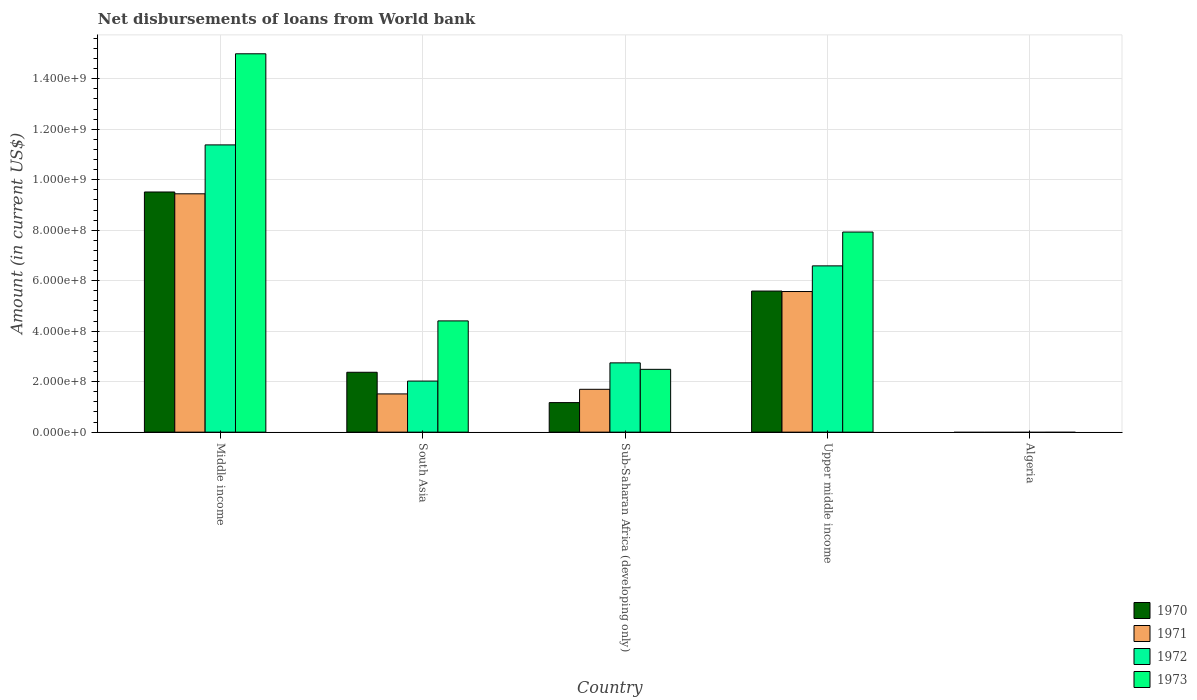How many different coloured bars are there?
Make the answer very short. 4. Are the number of bars on each tick of the X-axis equal?
Keep it short and to the point. No. How many bars are there on the 4th tick from the left?
Give a very brief answer. 4. How many bars are there on the 1st tick from the right?
Your response must be concise. 0. In how many cases, is the number of bars for a given country not equal to the number of legend labels?
Offer a terse response. 1. What is the amount of loan disbursed from World Bank in 1970 in Middle income?
Ensure brevity in your answer.  9.51e+08. Across all countries, what is the maximum amount of loan disbursed from World Bank in 1970?
Your answer should be very brief. 9.51e+08. In which country was the amount of loan disbursed from World Bank in 1973 maximum?
Give a very brief answer. Middle income. What is the total amount of loan disbursed from World Bank in 1973 in the graph?
Your response must be concise. 2.98e+09. What is the difference between the amount of loan disbursed from World Bank in 1971 in Sub-Saharan Africa (developing only) and that in Upper middle income?
Offer a terse response. -3.87e+08. What is the difference between the amount of loan disbursed from World Bank in 1972 in Upper middle income and the amount of loan disbursed from World Bank in 1971 in Middle income?
Provide a short and direct response. -2.85e+08. What is the average amount of loan disbursed from World Bank in 1973 per country?
Make the answer very short. 5.96e+08. What is the difference between the amount of loan disbursed from World Bank of/in 1973 and amount of loan disbursed from World Bank of/in 1971 in South Asia?
Ensure brevity in your answer.  2.89e+08. In how many countries, is the amount of loan disbursed from World Bank in 1970 greater than 40000000 US$?
Offer a very short reply. 4. What is the ratio of the amount of loan disbursed from World Bank in 1971 in Middle income to that in Upper middle income?
Offer a very short reply. 1.69. Is the difference between the amount of loan disbursed from World Bank in 1973 in Sub-Saharan Africa (developing only) and Upper middle income greater than the difference between the amount of loan disbursed from World Bank in 1971 in Sub-Saharan Africa (developing only) and Upper middle income?
Your answer should be very brief. No. What is the difference between the highest and the second highest amount of loan disbursed from World Bank in 1973?
Your answer should be very brief. 7.06e+08. What is the difference between the highest and the lowest amount of loan disbursed from World Bank in 1970?
Offer a very short reply. 9.51e+08. Is the sum of the amount of loan disbursed from World Bank in 1972 in South Asia and Upper middle income greater than the maximum amount of loan disbursed from World Bank in 1973 across all countries?
Give a very brief answer. No. Is it the case that in every country, the sum of the amount of loan disbursed from World Bank in 1970 and amount of loan disbursed from World Bank in 1973 is greater than the amount of loan disbursed from World Bank in 1972?
Provide a succinct answer. No. How many bars are there?
Offer a terse response. 16. How many countries are there in the graph?
Give a very brief answer. 5. What is the difference between two consecutive major ticks on the Y-axis?
Offer a very short reply. 2.00e+08. Are the values on the major ticks of Y-axis written in scientific E-notation?
Your answer should be compact. Yes. How many legend labels are there?
Give a very brief answer. 4. What is the title of the graph?
Your response must be concise. Net disbursements of loans from World bank. Does "2005" appear as one of the legend labels in the graph?
Ensure brevity in your answer.  No. What is the Amount (in current US$) in 1970 in Middle income?
Keep it short and to the point. 9.51e+08. What is the Amount (in current US$) of 1971 in Middle income?
Provide a succinct answer. 9.44e+08. What is the Amount (in current US$) of 1972 in Middle income?
Your response must be concise. 1.14e+09. What is the Amount (in current US$) in 1973 in Middle income?
Offer a very short reply. 1.50e+09. What is the Amount (in current US$) of 1970 in South Asia?
Make the answer very short. 2.37e+08. What is the Amount (in current US$) in 1971 in South Asia?
Provide a succinct answer. 1.51e+08. What is the Amount (in current US$) of 1972 in South Asia?
Make the answer very short. 2.02e+08. What is the Amount (in current US$) in 1973 in South Asia?
Your answer should be compact. 4.41e+08. What is the Amount (in current US$) in 1970 in Sub-Saharan Africa (developing only)?
Make the answer very short. 1.17e+08. What is the Amount (in current US$) of 1971 in Sub-Saharan Africa (developing only)?
Give a very brief answer. 1.70e+08. What is the Amount (in current US$) in 1972 in Sub-Saharan Africa (developing only)?
Provide a short and direct response. 2.74e+08. What is the Amount (in current US$) of 1973 in Sub-Saharan Africa (developing only)?
Keep it short and to the point. 2.49e+08. What is the Amount (in current US$) of 1970 in Upper middle income?
Provide a succinct answer. 5.59e+08. What is the Amount (in current US$) of 1971 in Upper middle income?
Provide a succinct answer. 5.57e+08. What is the Amount (in current US$) in 1972 in Upper middle income?
Offer a terse response. 6.59e+08. What is the Amount (in current US$) of 1973 in Upper middle income?
Offer a very short reply. 7.93e+08. What is the Amount (in current US$) in 1970 in Algeria?
Ensure brevity in your answer.  0. What is the Amount (in current US$) in 1972 in Algeria?
Provide a succinct answer. 0. What is the Amount (in current US$) of 1973 in Algeria?
Keep it short and to the point. 0. Across all countries, what is the maximum Amount (in current US$) of 1970?
Your response must be concise. 9.51e+08. Across all countries, what is the maximum Amount (in current US$) of 1971?
Offer a very short reply. 9.44e+08. Across all countries, what is the maximum Amount (in current US$) of 1972?
Keep it short and to the point. 1.14e+09. Across all countries, what is the maximum Amount (in current US$) of 1973?
Your response must be concise. 1.50e+09. Across all countries, what is the minimum Amount (in current US$) in 1970?
Ensure brevity in your answer.  0. Across all countries, what is the minimum Amount (in current US$) in 1971?
Offer a terse response. 0. Across all countries, what is the minimum Amount (in current US$) in 1972?
Offer a very short reply. 0. What is the total Amount (in current US$) of 1970 in the graph?
Your response must be concise. 1.86e+09. What is the total Amount (in current US$) in 1971 in the graph?
Provide a succinct answer. 1.82e+09. What is the total Amount (in current US$) in 1972 in the graph?
Ensure brevity in your answer.  2.27e+09. What is the total Amount (in current US$) in 1973 in the graph?
Ensure brevity in your answer.  2.98e+09. What is the difference between the Amount (in current US$) in 1970 in Middle income and that in South Asia?
Your response must be concise. 7.14e+08. What is the difference between the Amount (in current US$) in 1971 in Middle income and that in South Asia?
Ensure brevity in your answer.  7.93e+08. What is the difference between the Amount (in current US$) of 1972 in Middle income and that in South Asia?
Make the answer very short. 9.36e+08. What is the difference between the Amount (in current US$) in 1973 in Middle income and that in South Asia?
Your answer should be compact. 1.06e+09. What is the difference between the Amount (in current US$) of 1970 in Middle income and that in Sub-Saharan Africa (developing only)?
Ensure brevity in your answer.  8.34e+08. What is the difference between the Amount (in current US$) in 1971 in Middle income and that in Sub-Saharan Africa (developing only)?
Provide a short and direct response. 7.74e+08. What is the difference between the Amount (in current US$) in 1972 in Middle income and that in Sub-Saharan Africa (developing only)?
Ensure brevity in your answer.  8.63e+08. What is the difference between the Amount (in current US$) in 1973 in Middle income and that in Sub-Saharan Africa (developing only)?
Your response must be concise. 1.25e+09. What is the difference between the Amount (in current US$) in 1970 in Middle income and that in Upper middle income?
Provide a succinct answer. 3.92e+08. What is the difference between the Amount (in current US$) in 1971 in Middle income and that in Upper middle income?
Your answer should be very brief. 3.87e+08. What is the difference between the Amount (in current US$) in 1972 in Middle income and that in Upper middle income?
Your answer should be compact. 4.79e+08. What is the difference between the Amount (in current US$) of 1973 in Middle income and that in Upper middle income?
Provide a succinct answer. 7.06e+08. What is the difference between the Amount (in current US$) in 1970 in South Asia and that in Sub-Saharan Africa (developing only)?
Offer a terse response. 1.20e+08. What is the difference between the Amount (in current US$) of 1971 in South Asia and that in Sub-Saharan Africa (developing only)?
Ensure brevity in your answer.  -1.83e+07. What is the difference between the Amount (in current US$) of 1972 in South Asia and that in Sub-Saharan Africa (developing only)?
Keep it short and to the point. -7.21e+07. What is the difference between the Amount (in current US$) of 1973 in South Asia and that in Sub-Saharan Africa (developing only)?
Keep it short and to the point. 1.92e+08. What is the difference between the Amount (in current US$) of 1970 in South Asia and that in Upper middle income?
Your answer should be compact. -3.22e+08. What is the difference between the Amount (in current US$) of 1971 in South Asia and that in Upper middle income?
Offer a terse response. -4.06e+08. What is the difference between the Amount (in current US$) of 1972 in South Asia and that in Upper middle income?
Give a very brief answer. -4.56e+08. What is the difference between the Amount (in current US$) of 1973 in South Asia and that in Upper middle income?
Provide a short and direct response. -3.52e+08. What is the difference between the Amount (in current US$) of 1970 in Sub-Saharan Africa (developing only) and that in Upper middle income?
Provide a short and direct response. -4.42e+08. What is the difference between the Amount (in current US$) in 1971 in Sub-Saharan Africa (developing only) and that in Upper middle income?
Give a very brief answer. -3.87e+08. What is the difference between the Amount (in current US$) of 1972 in Sub-Saharan Africa (developing only) and that in Upper middle income?
Your response must be concise. -3.84e+08. What is the difference between the Amount (in current US$) in 1973 in Sub-Saharan Africa (developing only) and that in Upper middle income?
Your answer should be very brief. -5.44e+08. What is the difference between the Amount (in current US$) in 1970 in Middle income and the Amount (in current US$) in 1971 in South Asia?
Provide a succinct answer. 8.00e+08. What is the difference between the Amount (in current US$) in 1970 in Middle income and the Amount (in current US$) in 1972 in South Asia?
Make the answer very short. 7.49e+08. What is the difference between the Amount (in current US$) in 1970 in Middle income and the Amount (in current US$) in 1973 in South Asia?
Provide a succinct answer. 5.11e+08. What is the difference between the Amount (in current US$) of 1971 in Middle income and the Amount (in current US$) of 1972 in South Asia?
Make the answer very short. 7.42e+08. What is the difference between the Amount (in current US$) in 1971 in Middle income and the Amount (in current US$) in 1973 in South Asia?
Offer a very short reply. 5.03e+08. What is the difference between the Amount (in current US$) of 1972 in Middle income and the Amount (in current US$) of 1973 in South Asia?
Offer a very short reply. 6.97e+08. What is the difference between the Amount (in current US$) of 1970 in Middle income and the Amount (in current US$) of 1971 in Sub-Saharan Africa (developing only)?
Offer a very short reply. 7.82e+08. What is the difference between the Amount (in current US$) of 1970 in Middle income and the Amount (in current US$) of 1972 in Sub-Saharan Africa (developing only)?
Ensure brevity in your answer.  6.77e+08. What is the difference between the Amount (in current US$) in 1970 in Middle income and the Amount (in current US$) in 1973 in Sub-Saharan Africa (developing only)?
Provide a succinct answer. 7.03e+08. What is the difference between the Amount (in current US$) in 1971 in Middle income and the Amount (in current US$) in 1972 in Sub-Saharan Africa (developing only)?
Make the answer very short. 6.70e+08. What is the difference between the Amount (in current US$) of 1971 in Middle income and the Amount (in current US$) of 1973 in Sub-Saharan Africa (developing only)?
Make the answer very short. 6.95e+08. What is the difference between the Amount (in current US$) in 1972 in Middle income and the Amount (in current US$) in 1973 in Sub-Saharan Africa (developing only)?
Offer a terse response. 8.89e+08. What is the difference between the Amount (in current US$) of 1970 in Middle income and the Amount (in current US$) of 1971 in Upper middle income?
Keep it short and to the point. 3.94e+08. What is the difference between the Amount (in current US$) in 1970 in Middle income and the Amount (in current US$) in 1972 in Upper middle income?
Your answer should be compact. 2.93e+08. What is the difference between the Amount (in current US$) of 1970 in Middle income and the Amount (in current US$) of 1973 in Upper middle income?
Keep it short and to the point. 1.59e+08. What is the difference between the Amount (in current US$) of 1971 in Middle income and the Amount (in current US$) of 1972 in Upper middle income?
Give a very brief answer. 2.85e+08. What is the difference between the Amount (in current US$) in 1971 in Middle income and the Amount (in current US$) in 1973 in Upper middle income?
Provide a short and direct response. 1.51e+08. What is the difference between the Amount (in current US$) of 1972 in Middle income and the Amount (in current US$) of 1973 in Upper middle income?
Your response must be concise. 3.45e+08. What is the difference between the Amount (in current US$) of 1970 in South Asia and the Amount (in current US$) of 1971 in Sub-Saharan Africa (developing only)?
Offer a very short reply. 6.75e+07. What is the difference between the Amount (in current US$) of 1970 in South Asia and the Amount (in current US$) of 1972 in Sub-Saharan Africa (developing only)?
Offer a very short reply. -3.73e+07. What is the difference between the Amount (in current US$) in 1970 in South Asia and the Amount (in current US$) in 1973 in Sub-Saharan Africa (developing only)?
Make the answer very short. -1.16e+07. What is the difference between the Amount (in current US$) in 1971 in South Asia and the Amount (in current US$) in 1972 in Sub-Saharan Africa (developing only)?
Your response must be concise. -1.23e+08. What is the difference between the Amount (in current US$) in 1971 in South Asia and the Amount (in current US$) in 1973 in Sub-Saharan Africa (developing only)?
Your response must be concise. -9.74e+07. What is the difference between the Amount (in current US$) of 1972 in South Asia and the Amount (in current US$) of 1973 in Sub-Saharan Africa (developing only)?
Keep it short and to the point. -4.65e+07. What is the difference between the Amount (in current US$) in 1970 in South Asia and the Amount (in current US$) in 1971 in Upper middle income?
Offer a very short reply. -3.20e+08. What is the difference between the Amount (in current US$) in 1970 in South Asia and the Amount (in current US$) in 1972 in Upper middle income?
Offer a terse response. -4.22e+08. What is the difference between the Amount (in current US$) of 1970 in South Asia and the Amount (in current US$) of 1973 in Upper middle income?
Ensure brevity in your answer.  -5.56e+08. What is the difference between the Amount (in current US$) of 1971 in South Asia and the Amount (in current US$) of 1972 in Upper middle income?
Provide a succinct answer. -5.07e+08. What is the difference between the Amount (in current US$) of 1971 in South Asia and the Amount (in current US$) of 1973 in Upper middle income?
Your response must be concise. -6.41e+08. What is the difference between the Amount (in current US$) of 1972 in South Asia and the Amount (in current US$) of 1973 in Upper middle income?
Give a very brief answer. -5.90e+08. What is the difference between the Amount (in current US$) of 1970 in Sub-Saharan Africa (developing only) and the Amount (in current US$) of 1971 in Upper middle income?
Provide a short and direct response. -4.40e+08. What is the difference between the Amount (in current US$) in 1970 in Sub-Saharan Africa (developing only) and the Amount (in current US$) in 1972 in Upper middle income?
Provide a succinct answer. -5.42e+08. What is the difference between the Amount (in current US$) in 1970 in Sub-Saharan Africa (developing only) and the Amount (in current US$) in 1973 in Upper middle income?
Offer a terse response. -6.76e+08. What is the difference between the Amount (in current US$) in 1971 in Sub-Saharan Africa (developing only) and the Amount (in current US$) in 1972 in Upper middle income?
Make the answer very short. -4.89e+08. What is the difference between the Amount (in current US$) in 1971 in Sub-Saharan Africa (developing only) and the Amount (in current US$) in 1973 in Upper middle income?
Make the answer very short. -6.23e+08. What is the difference between the Amount (in current US$) of 1972 in Sub-Saharan Africa (developing only) and the Amount (in current US$) of 1973 in Upper middle income?
Offer a very short reply. -5.18e+08. What is the average Amount (in current US$) in 1970 per country?
Your answer should be compact. 3.73e+08. What is the average Amount (in current US$) of 1971 per country?
Offer a very short reply. 3.64e+08. What is the average Amount (in current US$) in 1972 per country?
Provide a short and direct response. 4.55e+08. What is the average Amount (in current US$) in 1973 per country?
Ensure brevity in your answer.  5.96e+08. What is the difference between the Amount (in current US$) of 1970 and Amount (in current US$) of 1971 in Middle income?
Offer a terse response. 7.21e+06. What is the difference between the Amount (in current US$) of 1970 and Amount (in current US$) of 1972 in Middle income?
Your answer should be compact. -1.87e+08. What is the difference between the Amount (in current US$) of 1970 and Amount (in current US$) of 1973 in Middle income?
Your answer should be very brief. -5.47e+08. What is the difference between the Amount (in current US$) in 1971 and Amount (in current US$) in 1972 in Middle income?
Your answer should be very brief. -1.94e+08. What is the difference between the Amount (in current US$) of 1971 and Amount (in current US$) of 1973 in Middle income?
Provide a succinct answer. -5.55e+08. What is the difference between the Amount (in current US$) in 1972 and Amount (in current US$) in 1973 in Middle income?
Provide a short and direct response. -3.61e+08. What is the difference between the Amount (in current US$) of 1970 and Amount (in current US$) of 1971 in South Asia?
Give a very brief answer. 8.58e+07. What is the difference between the Amount (in current US$) of 1970 and Amount (in current US$) of 1972 in South Asia?
Your response must be concise. 3.49e+07. What is the difference between the Amount (in current US$) of 1970 and Amount (in current US$) of 1973 in South Asia?
Provide a succinct answer. -2.04e+08. What is the difference between the Amount (in current US$) of 1971 and Amount (in current US$) of 1972 in South Asia?
Offer a terse response. -5.09e+07. What is the difference between the Amount (in current US$) of 1971 and Amount (in current US$) of 1973 in South Asia?
Provide a short and direct response. -2.89e+08. What is the difference between the Amount (in current US$) of 1972 and Amount (in current US$) of 1973 in South Asia?
Give a very brief answer. -2.38e+08. What is the difference between the Amount (in current US$) in 1970 and Amount (in current US$) in 1971 in Sub-Saharan Africa (developing only)?
Your response must be concise. -5.27e+07. What is the difference between the Amount (in current US$) in 1970 and Amount (in current US$) in 1972 in Sub-Saharan Africa (developing only)?
Your answer should be very brief. -1.57e+08. What is the difference between the Amount (in current US$) in 1970 and Amount (in current US$) in 1973 in Sub-Saharan Africa (developing only)?
Ensure brevity in your answer.  -1.32e+08. What is the difference between the Amount (in current US$) in 1971 and Amount (in current US$) in 1972 in Sub-Saharan Africa (developing only)?
Provide a succinct answer. -1.05e+08. What is the difference between the Amount (in current US$) of 1971 and Amount (in current US$) of 1973 in Sub-Saharan Africa (developing only)?
Your response must be concise. -7.91e+07. What is the difference between the Amount (in current US$) of 1972 and Amount (in current US$) of 1973 in Sub-Saharan Africa (developing only)?
Provide a short and direct response. 2.57e+07. What is the difference between the Amount (in current US$) of 1970 and Amount (in current US$) of 1971 in Upper middle income?
Offer a terse response. 1.84e+06. What is the difference between the Amount (in current US$) in 1970 and Amount (in current US$) in 1972 in Upper middle income?
Give a very brief answer. -9.98e+07. What is the difference between the Amount (in current US$) of 1970 and Amount (in current US$) of 1973 in Upper middle income?
Offer a terse response. -2.34e+08. What is the difference between the Amount (in current US$) of 1971 and Amount (in current US$) of 1972 in Upper middle income?
Ensure brevity in your answer.  -1.02e+08. What is the difference between the Amount (in current US$) in 1971 and Amount (in current US$) in 1973 in Upper middle income?
Your answer should be compact. -2.36e+08. What is the difference between the Amount (in current US$) of 1972 and Amount (in current US$) of 1973 in Upper middle income?
Your answer should be compact. -1.34e+08. What is the ratio of the Amount (in current US$) in 1970 in Middle income to that in South Asia?
Provide a short and direct response. 4.01. What is the ratio of the Amount (in current US$) of 1971 in Middle income to that in South Asia?
Keep it short and to the point. 6.23. What is the ratio of the Amount (in current US$) of 1972 in Middle income to that in South Asia?
Keep it short and to the point. 5.62. What is the ratio of the Amount (in current US$) in 1973 in Middle income to that in South Asia?
Give a very brief answer. 3.4. What is the ratio of the Amount (in current US$) of 1970 in Middle income to that in Sub-Saharan Africa (developing only)?
Your answer should be compact. 8.13. What is the ratio of the Amount (in current US$) in 1971 in Middle income to that in Sub-Saharan Africa (developing only)?
Provide a short and direct response. 5.56. What is the ratio of the Amount (in current US$) of 1972 in Middle income to that in Sub-Saharan Africa (developing only)?
Provide a succinct answer. 4.15. What is the ratio of the Amount (in current US$) of 1973 in Middle income to that in Sub-Saharan Africa (developing only)?
Provide a short and direct response. 6.02. What is the ratio of the Amount (in current US$) of 1970 in Middle income to that in Upper middle income?
Offer a very short reply. 1.7. What is the ratio of the Amount (in current US$) of 1971 in Middle income to that in Upper middle income?
Make the answer very short. 1.69. What is the ratio of the Amount (in current US$) of 1972 in Middle income to that in Upper middle income?
Your answer should be very brief. 1.73. What is the ratio of the Amount (in current US$) in 1973 in Middle income to that in Upper middle income?
Give a very brief answer. 1.89. What is the ratio of the Amount (in current US$) in 1970 in South Asia to that in Sub-Saharan Africa (developing only)?
Your answer should be very brief. 2.03. What is the ratio of the Amount (in current US$) of 1971 in South Asia to that in Sub-Saharan Africa (developing only)?
Offer a very short reply. 0.89. What is the ratio of the Amount (in current US$) of 1972 in South Asia to that in Sub-Saharan Africa (developing only)?
Make the answer very short. 0.74. What is the ratio of the Amount (in current US$) in 1973 in South Asia to that in Sub-Saharan Africa (developing only)?
Your answer should be compact. 1.77. What is the ratio of the Amount (in current US$) in 1970 in South Asia to that in Upper middle income?
Ensure brevity in your answer.  0.42. What is the ratio of the Amount (in current US$) in 1971 in South Asia to that in Upper middle income?
Make the answer very short. 0.27. What is the ratio of the Amount (in current US$) of 1972 in South Asia to that in Upper middle income?
Offer a very short reply. 0.31. What is the ratio of the Amount (in current US$) in 1973 in South Asia to that in Upper middle income?
Your answer should be compact. 0.56. What is the ratio of the Amount (in current US$) of 1970 in Sub-Saharan Africa (developing only) to that in Upper middle income?
Provide a short and direct response. 0.21. What is the ratio of the Amount (in current US$) in 1971 in Sub-Saharan Africa (developing only) to that in Upper middle income?
Ensure brevity in your answer.  0.3. What is the ratio of the Amount (in current US$) in 1972 in Sub-Saharan Africa (developing only) to that in Upper middle income?
Make the answer very short. 0.42. What is the ratio of the Amount (in current US$) of 1973 in Sub-Saharan Africa (developing only) to that in Upper middle income?
Give a very brief answer. 0.31. What is the difference between the highest and the second highest Amount (in current US$) of 1970?
Your answer should be compact. 3.92e+08. What is the difference between the highest and the second highest Amount (in current US$) in 1971?
Keep it short and to the point. 3.87e+08. What is the difference between the highest and the second highest Amount (in current US$) in 1972?
Keep it short and to the point. 4.79e+08. What is the difference between the highest and the second highest Amount (in current US$) of 1973?
Give a very brief answer. 7.06e+08. What is the difference between the highest and the lowest Amount (in current US$) of 1970?
Your answer should be very brief. 9.51e+08. What is the difference between the highest and the lowest Amount (in current US$) in 1971?
Provide a succinct answer. 9.44e+08. What is the difference between the highest and the lowest Amount (in current US$) in 1972?
Provide a succinct answer. 1.14e+09. What is the difference between the highest and the lowest Amount (in current US$) in 1973?
Make the answer very short. 1.50e+09. 